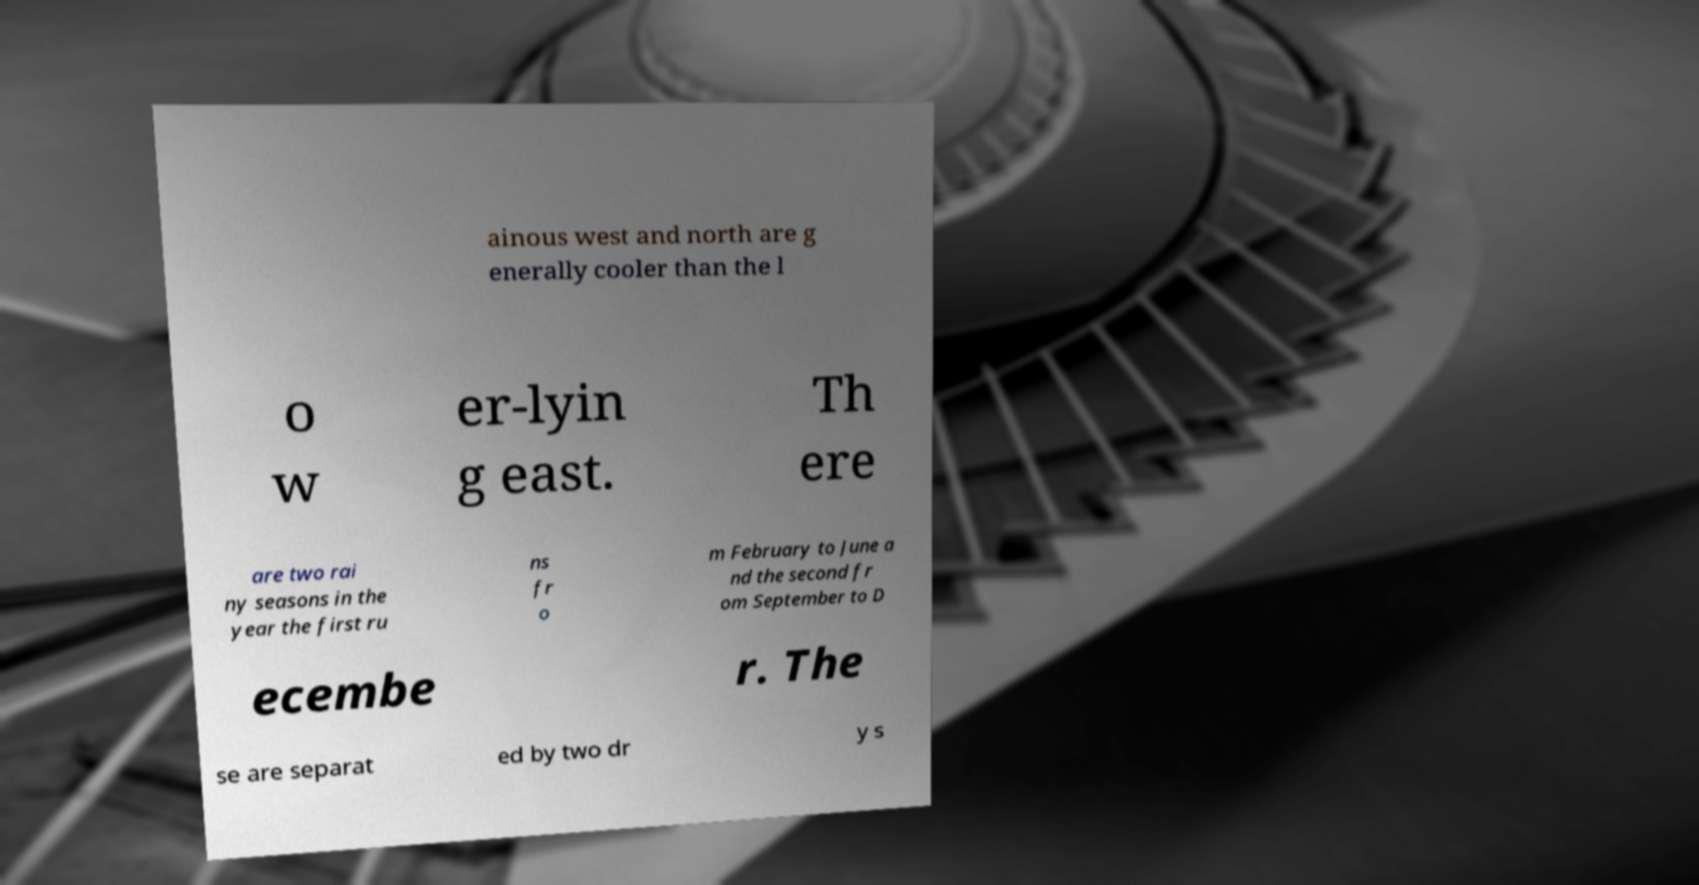Could you assist in decoding the text presented in this image and type it out clearly? ainous west and north are g enerally cooler than the l o w er-lyin g east. Th ere are two rai ny seasons in the year the first ru ns fr o m February to June a nd the second fr om September to D ecembe r. The se are separat ed by two dr y s 